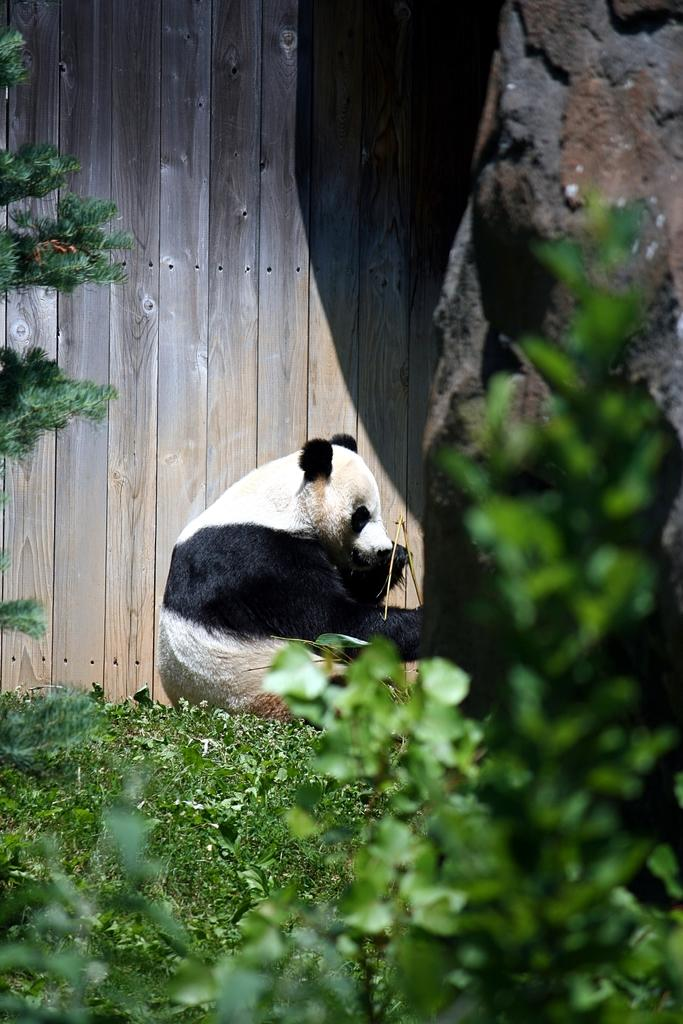What animal is in the center of the image? There is a panda in the center of the image. What is the panda sitting on? The panda is sitting on the grass. What can be seen in the background of the image? There is a wooden wall in the background of the image. What type of vegetation is on the right side of the image? There are plants on the right side of the image. What type of silk is being produced by the panda in the image? There is no silk production mentioned or depicted in the image; it features a panda sitting on the grass. How does the panda's death contribute to the image? There is no mention or depiction of the panda's death in the image; the panda is sitting on the grass. 